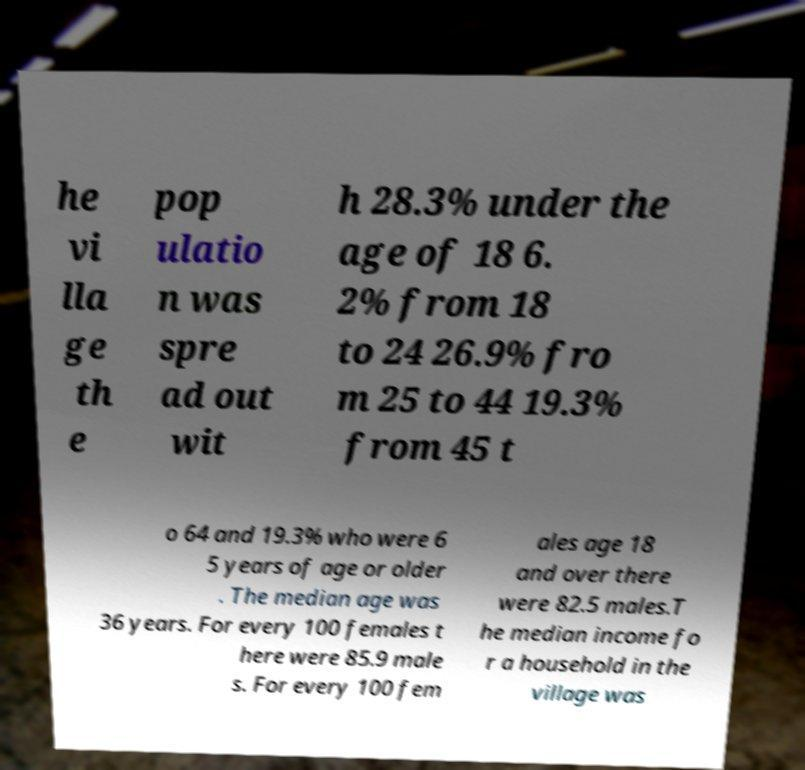I need the written content from this picture converted into text. Can you do that? he vi lla ge th e pop ulatio n was spre ad out wit h 28.3% under the age of 18 6. 2% from 18 to 24 26.9% fro m 25 to 44 19.3% from 45 t o 64 and 19.3% who were 6 5 years of age or older . The median age was 36 years. For every 100 females t here were 85.9 male s. For every 100 fem ales age 18 and over there were 82.5 males.T he median income fo r a household in the village was 